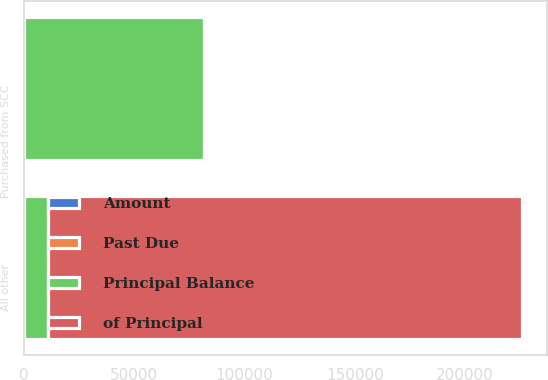Convert chart. <chart><loc_0><loc_0><loc_500><loc_500><stacked_bar_chart><ecel><fcel>Purchased from SCC<fcel>All other<nl><fcel>of Principal<fcel>41.7<fcel>215160<nl><fcel>Principal Balance<fcel>81396<fcel>10691<nl><fcel>Past Due<fcel>22.7<fcel>5<nl><fcel>Amount<fcel>41.7<fcel>11<nl></chart> 